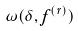<formula> <loc_0><loc_0><loc_500><loc_500>\omega ( \delta , f ^ { ( r ) } )</formula> 